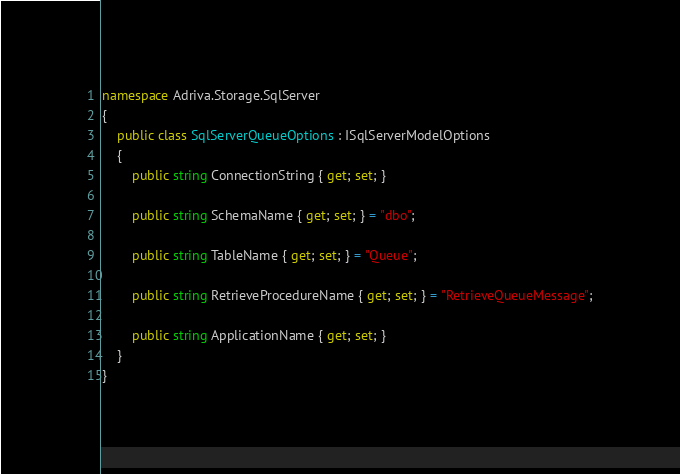<code> <loc_0><loc_0><loc_500><loc_500><_C#_>namespace Adriva.Storage.SqlServer
{
    public class SqlServerQueueOptions : ISqlServerModelOptions
    {
        public string ConnectionString { get; set; }

        public string SchemaName { get; set; } = "dbo";

        public string TableName { get; set; } = "Queue";

        public string RetrieveProcedureName { get; set; } = "RetrieveQueueMessage";

        public string ApplicationName { get; set; }
    }
}
</code> 